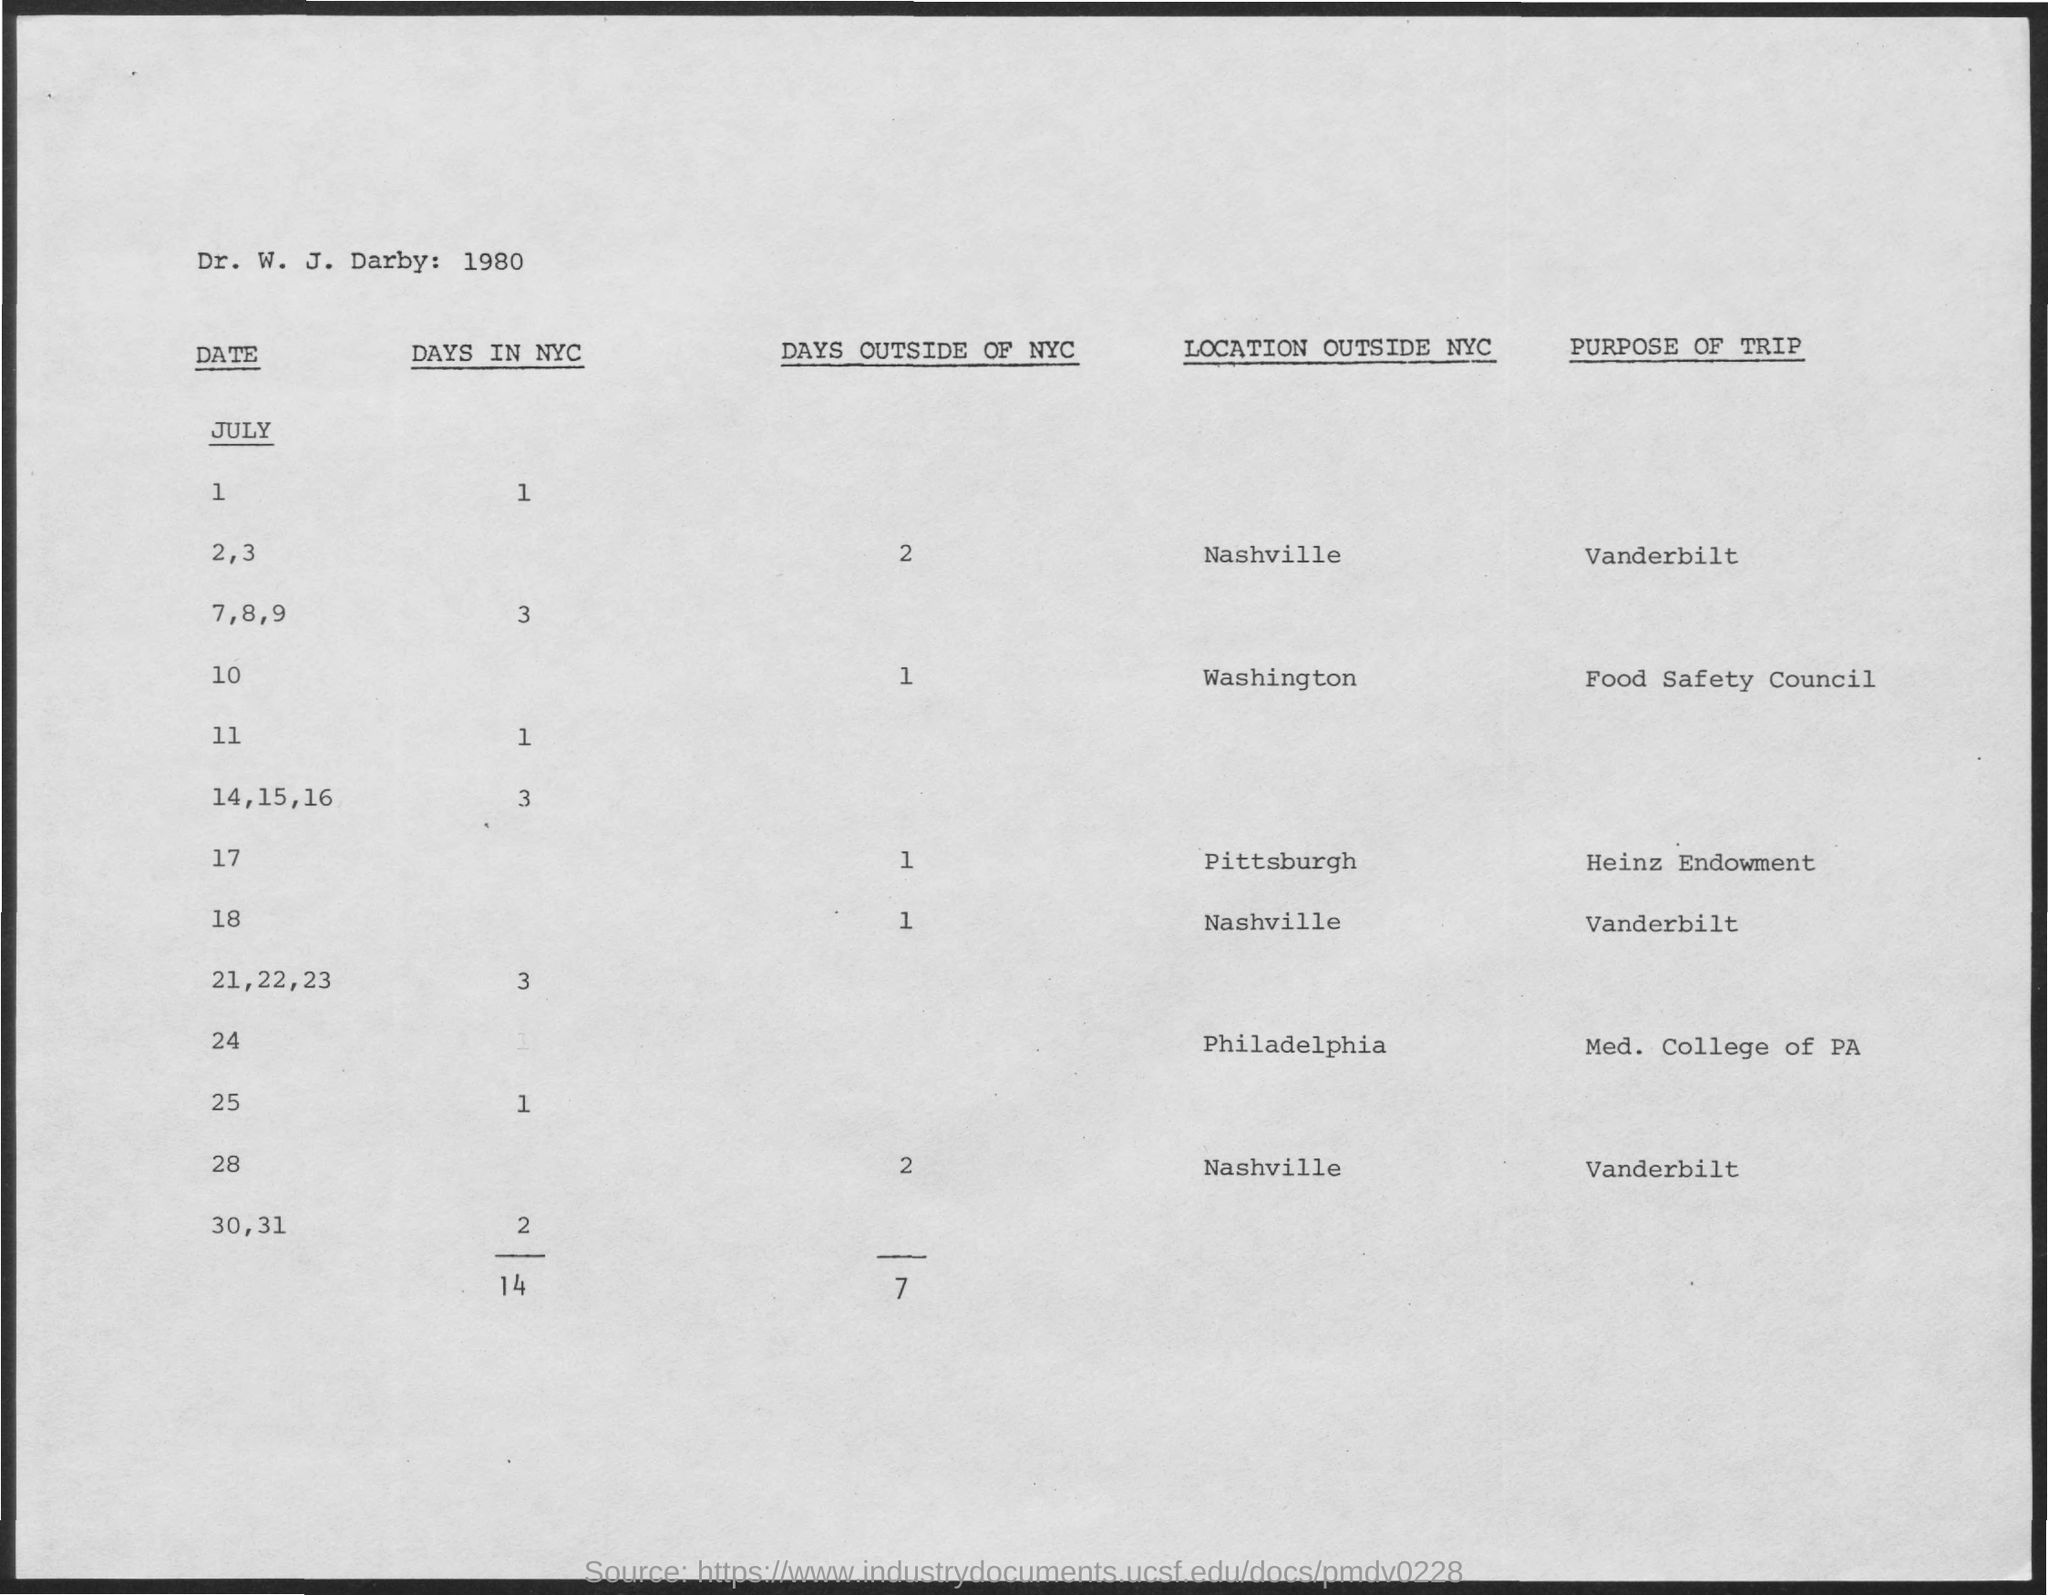What is the total number of days in NYC?
Provide a succinct answer. 14. What is the total number of days outside of NYC?
Give a very brief answer. 7. What is the purpose of trip on July 28?
Provide a short and direct response. Vanderbilt. 